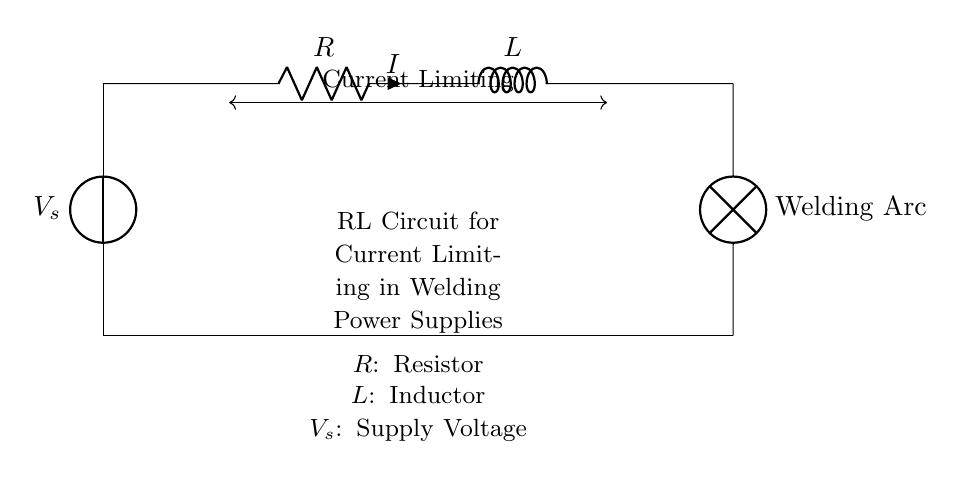What is the function of the resistor in this circuit? The resistor limits the current flowing through the circuit, providing protection to components and ensuring appropriate operation during welding.
Answer: Current limiting What is the labeled current in this circuit? The circuit diagram indicates that the current is labeled as 'I', which signifies the current flowing through the resistor and inductor.
Answer: I What component is directly connected to the voltage source? The component directly connected to the voltage source is the resistor, as it is the first element in the series circuit immediately following the voltage source.
Answer: Resistor What does the presence of the inductor indicate about the circuit's response? The presence of the inductor implies that the circuit has characteristics of inductance, meaning it will resist sudden changes in current, benefiting applications requiring stable current during welding.
Answer: Inductive response How does the circuit limit the current when operating? The current limiting occurs because the resistor converts electrical energy into heat, while the inductor reacts to changes in current, together moderating the instantaneous flow of current in the circuit.
Answer: Resistor and inductor interaction What is the purpose of the welding arc in the circuit? The welding arc serves as the load where the actual welding operation occurs, utilizing the controlled current supplied by the circuit to create a weld.
Answer: Load What electrical feature does the inductor add to the circuit? The inductor adds inductance, which stores energy in a magnetic field and helps maintain a steady current flow, especially important in welding applications where stability is critical.
Answer: Inductance 